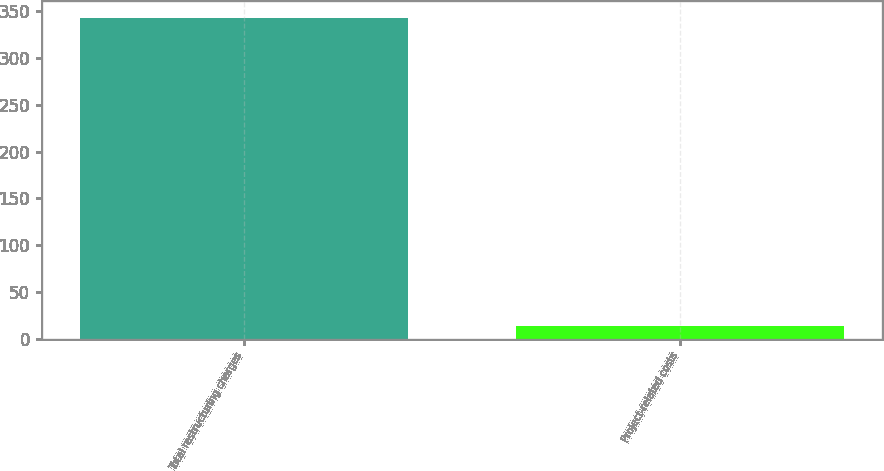Convert chart to OTSL. <chart><loc_0><loc_0><loc_500><loc_500><bar_chart><fcel>Total restructuring charges<fcel>Project-related costs<nl><fcel>343.5<fcel>13.2<nl></chart> 